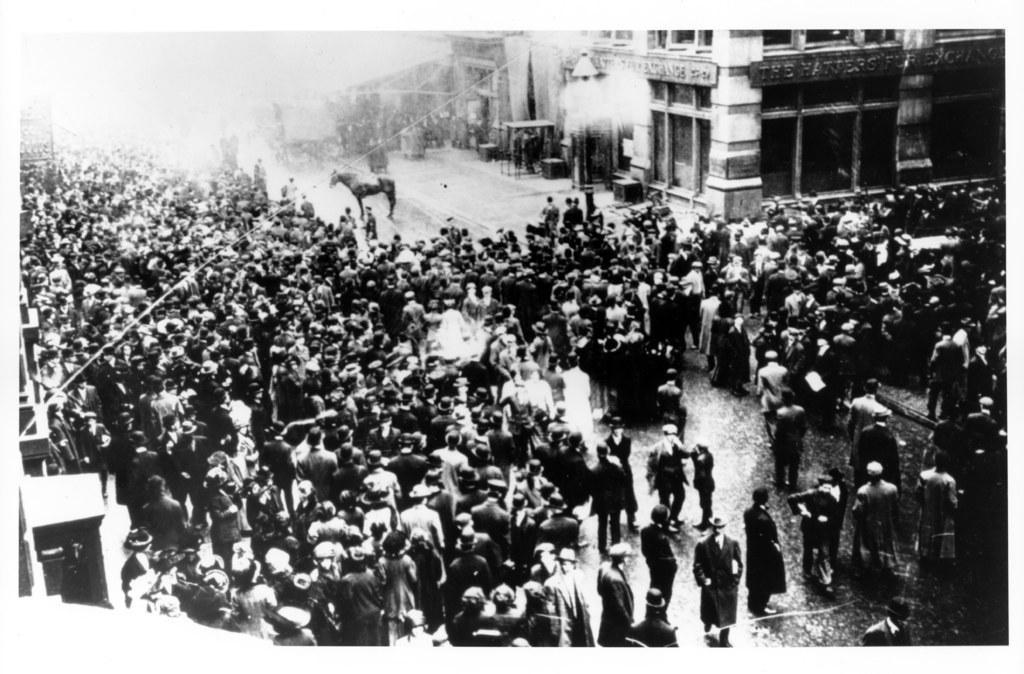In one or two sentences, can you explain what this image depicts? In this black and white picture there are many people standing on the road. Beside them there is a horse standing on the road. At the top there are buildings. 